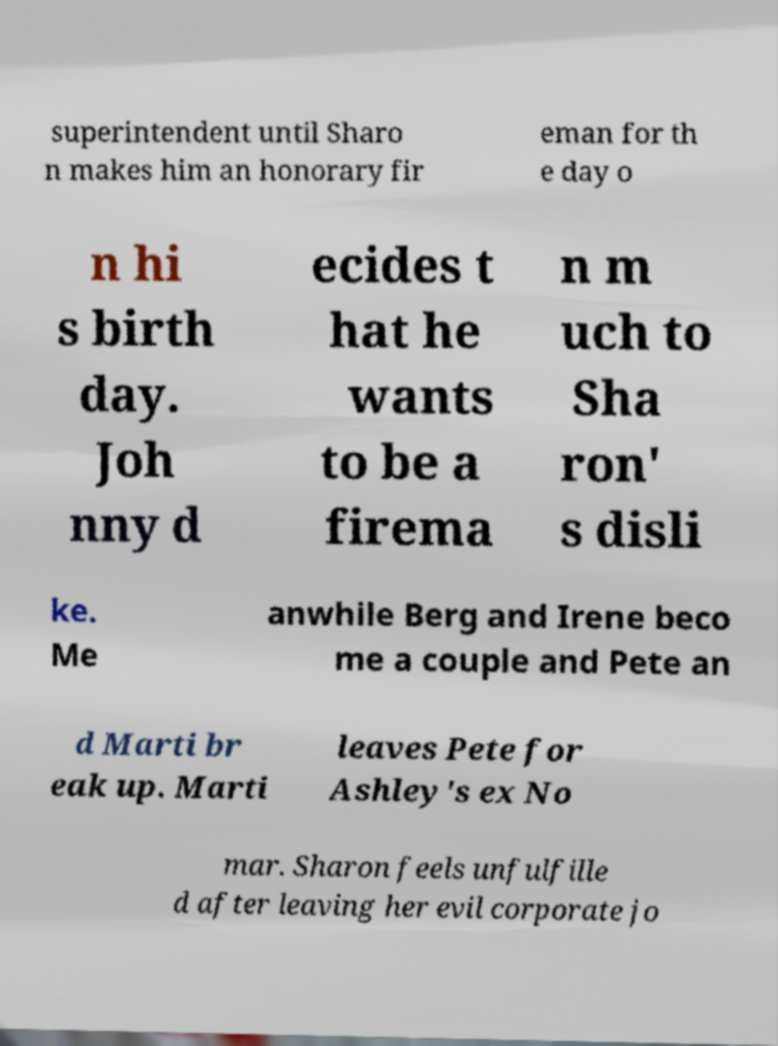Can you read and provide the text displayed in the image?This photo seems to have some interesting text. Can you extract and type it out for me? superintendent until Sharo n makes him an honorary fir eman for th e day o n hi s birth day. Joh nny d ecides t hat he wants to be a firema n m uch to Sha ron' s disli ke. Me anwhile Berg and Irene beco me a couple and Pete an d Marti br eak up. Marti leaves Pete for Ashley's ex No mar. Sharon feels unfulfille d after leaving her evil corporate jo 